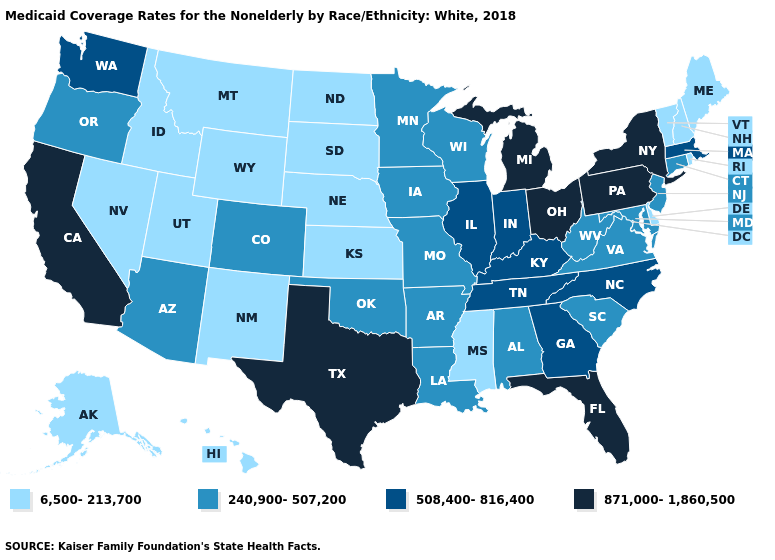Among the states that border Utah , which have the lowest value?
Write a very short answer. Idaho, Nevada, New Mexico, Wyoming. What is the highest value in the USA?
Short answer required. 871,000-1,860,500. Does North Dakota have the lowest value in the USA?
Keep it brief. Yes. Name the states that have a value in the range 240,900-507,200?
Keep it brief. Alabama, Arizona, Arkansas, Colorado, Connecticut, Iowa, Louisiana, Maryland, Minnesota, Missouri, New Jersey, Oklahoma, Oregon, South Carolina, Virginia, West Virginia, Wisconsin. What is the highest value in the USA?
Short answer required. 871,000-1,860,500. Name the states that have a value in the range 508,400-816,400?
Keep it brief. Georgia, Illinois, Indiana, Kentucky, Massachusetts, North Carolina, Tennessee, Washington. What is the value of Missouri?
Write a very short answer. 240,900-507,200. Name the states that have a value in the range 508,400-816,400?
Keep it brief. Georgia, Illinois, Indiana, Kentucky, Massachusetts, North Carolina, Tennessee, Washington. Which states have the highest value in the USA?
Short answer required. California, Florida, Michigan, New York, Ohio, Pennsylvania, Texas. What is the value of Maryland?
Write a very short answer. 240,900-507,200. Is the legend a continuous bar?
Concise answer only. No. What is the highest value in states that border Kansas?
Answer briefly. 240,900-507,200. Which states hav the highest value in the West?
Give a very brief answer. California. What is the value of Connecticut?
Quick response, please. 240,900-507,200. What is the lowest value in the USA?
Be succinct. 6,500-213,700. 